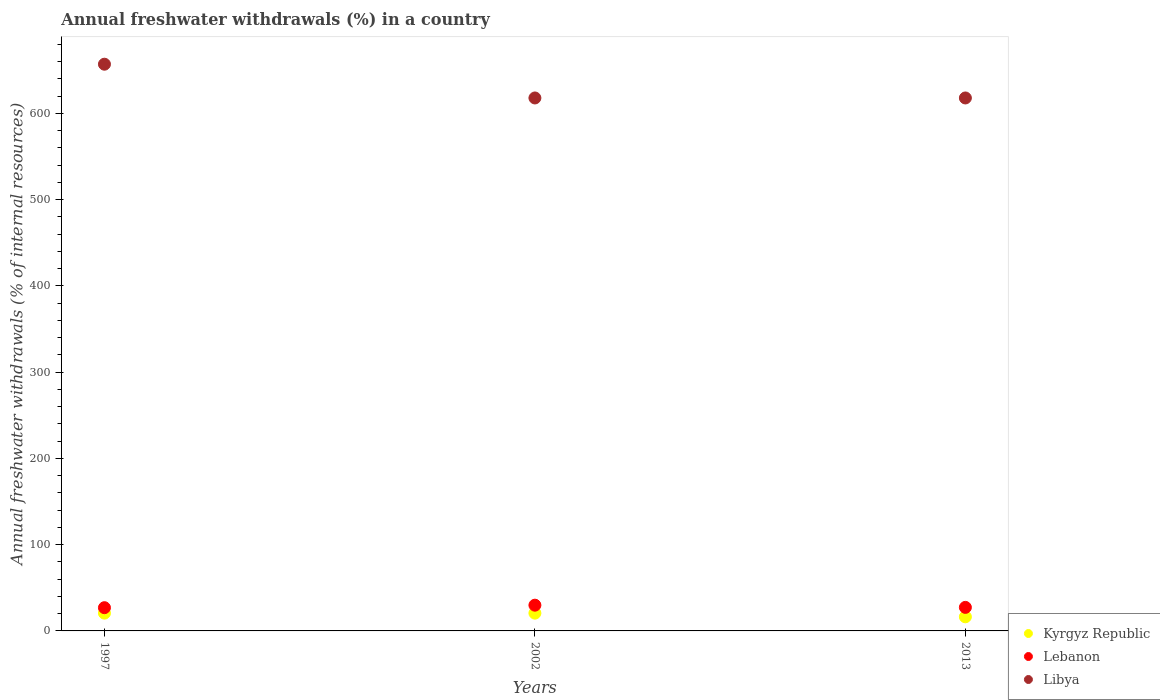How many different coloured dotlines are there?
Ensure brevity in your answer.  3. What is the percentage of annual freshwater withdrawals in Libya in 1997?
Ensure brevity in your answer.  657.14. Across all years, what is the maximum percentage of annual freshwater withdrawals in Kyrgyz Republic?
Provide a succinct answer. 20.62. Across all years, what is the minimum percentage of annual freshwater withdrawals in Lebanon?
Provide a succinct answer. 26.94. In which year was the percentage of annual freshwater withdrawals in Lebanon maximum?
Ensure brevity in your answer.  2002. What is the total percentage of annual freshwater withdrawals in Libya in the graph?
Make the answer very short. 1893.14. What is the difference between the percentage of annual freshwater withdrawals in Kyrgyz Republic in 2002 and that in 2013?
Give a very brief answer. 4.24. What is the difference between the percentage of annual freshwater withdrawals in Libya in 2013 and the percentage of annual freshwater withdrawals in Kyrgyz Republic in 1997?
Provide a succinct answer. 597.38. What is the average percentage of annual freshwater withdrawals in Libya per year?
Your response must be concise. 631.05. In the year 2013, what is the difference between the percentage of annual freshwater withdrawals in Lebanon and percentage of annual freshwater withdrawals in Kyrgyz Republic?
Offer a very short reply. 10.93. What is the ratio of the percentage of annual freshwater withdrawals in Lebanon in 1997 to that in 2002?
Provide a short and direct response. 0.9. Is the percentage of annual freshwater withdrawals in Libya in 2002 less than that in 2013?
Your answer should be very brief. No. Is the difference between the percentage of annual freshwater withdrawals in Lebanon in 1997 and 2002 greater than the difference between the percentage of annual freshwater withdrawals in Kyrgyz Republic in 1997 and 2002?
Provide a succinct answer. No. What is the difference between the highest and the second highest percentage of annual freshwater withdrawals in Kyrgyz Republic?
Make the answer very short. 0.02. What is the difference between the highest and the lowest percentage of annual freshwater withdrawals in Libya?
Provide a succinct answer. 39.14. In how many years, is the percentage of annual freshwater withdrawals in Kyrgyz Republic greater than the average percentage of annual freshwater withdrawals in Kyrgyz Republic taken over all years?
Make the answer very short. 2. Is it the case that in every year, the sum of the percentage of annual freshwater withdrawals in Lebanon and percentage of annual freshwater withdrawals in Kyrgyz Republic  is greater than the percentage of annual freshwater withdrawals in Libya?
Make the answer very short. No. Does the percentage of annual freshwater withdrawals in Lebanon monotonically increase over the years?
Ensure brevity in your answer.  No. Is the percentage of annual freshwater withdrawals in Kyrgyz Republic strictly less than the percentage of annual freshwater withdrawals in Lebanon over the years?
Your answer should be very brief. Yes. How many dotlines are there?
Your response must be concise. 3. What is the difference between two consecutive major ticks on the Y-axis?
Your answer should be compact. 100. Are the values on the major ticks of Y-axis written in scientific E-notation?
Provide a succinct answer. No. Does the graph contain any zero values?
Provide a short and direct response. No. What is the title of the graph?
Offer a very short reply. Annual freshwater withdrawals (%) in a country. Does "Swaziland" appear as one of the legend labels in the graph?
Your answer should be very brief. No. What is the label or title of the Y-axis?
Your response must be concise. Annual freshwater withdrawals (% of internal resources). What is the Annual freshwater withdrawals (% of internal resources) of Kyrgyz Republic in 1997?
Keep it short and to the point. 20.62. What is the Annual freshwater withdrawals (% of internal resources) of Lebanon in 1997?
Provide a short and direct response. 26.94. What is the Annual freshwater withdrawals (% of internal resources) in Libya in 1997?
Your answer should be compact. 657.14. What is the Annual freshwater withdrawals (% of internal resources) in Kyrgyz Republic in 2002?
Your response must be concise. 20.6. What is the Annual freshwater withdrawals (% of internal resources) of Lebanon in 2002?
Your answer should be very brief. 29.85. What is the Annual freshwater withdrawals (% of internal resources) of Libya in 2002?
Your answer should be compact. 618. What is the Annual freshwater withdrawals (% of internal resources) in Kyrgyz Republic in 2013?
Your answer should be compact. 16.36. What is the Annual freshwater withdrawals (% of internal resources) in Lebanon in 2013?
Make the answer very short. 27.29. What is the Annual freshwater withdrawals (% of internal resources) of Libya in 2013?
Provide a short and direct response. 618. Across all years, what is the maximum Annual freshwater withdrawals (% of internal resources) of Kyrgyz Republic?
Offer a very short reply. 20.62. Across all years, what is the maximum Annual freshwater withdrawals (% of internal resources) of Lebanon?
Offer a terse response. 29.85. Across all years, what is the maximum Annual freshwater withdrawals (% of internal resources) in Libya?
Offer a very short reply. 657.14. Across all years, what is the minimum Annual freshwater withdrawals (% of internal resources) in Kyrgyz Republic?
Give a very brief answer. 16.36. Across all years, what is the minimum Annual freshwater withdrawals (% of internal resources) in Lebanon?
Offer a very short reply. 26.94. Across all years, what is the minimum Annual freshwater withdrawals (% of internal resources) in Libya?
Keep it short and to the point. 618. What is the total Annual freshwater withdrawals (% of internal resources) in Kyrgyz Republic in the graph?
Give a very brief answer. 57.59. What is the total Annual freshwater withdrawals (% of internal resources) of Lebanon in the graph?
Give a very brief answer. 84.08. What is the total Annual freshwater withdrawals (% of internal resources) of Libya in the graph?
Ensure brevity in your answer.  1893.14. What is the difference between the Annual freshwater withdrawals (% of internal resources) of Kyrgyz Republic in 1997 and that in 2002?
Give a very brief answer. 0.02. What is the difference between the Annual freshwater withdrawals (% of internal resources) in Lebanon in 1997 and that in 2002?
Offer a very short reply. -2.92. What is the difference between the Annual freshwater withdrawals (% of internal resources) of Libya in 1997 and that in 2002?
Keep it short and to the point. 39.14. What is the difference between the Annual freshwater withdrawals (% of internal resources) in Kyrgyz Republic in 1997 and that in 2013?
Provide a short and direct response. 4.26. What is the difference between the Annual freshwater withdrawals (% of internal resources) in Lebanon in 1997 and that in 2013?
Provide a succinct answer. -0.35. What is the difference between the Annual freshwater withdrawals (% of internal resources) of Libya in 1997 and that in 2013?
Your answer should be compact. 39.14. What is the difference between the Annual freshwater withdrawals (% of internal resources) in Kyrgyz Republic in 2002 and that in 2013?
Provide a short and direct response. 4.24. What is the difference between the Annual freshwater withdrawals (% of internal resources) in Lebanon in 2002 and that in 2013?
Provide a succinct answer. 2.56. What is the difference between the Annual freshwater withdrawals (% of internal resources) of Kyrgyz Republic in 1997 and the Annual freshwater withdrawals (% of internal resources) of Lebanon in 2002?
Provide a short and direct response. -9.23. What is the difference between the Annual freshwater withdrawals (% of internal resources) of Kyrgyz Republic in 1997 and the Annual freshwater withdrawals (% of internal resources) of Libya in 2002?
Give a very brief answer. -597.38. What is the difference between the Annual freshwater withdrawals (% of internal resources) in Lebanon in 1997 and the Annual freshwater withdrawals (% of internal resources) in Libya in 2002?
Your answer should be very brief. -591.06. What is the difference between the Annual freshwater withdrawals (% of internal resources) in Kyrgyz Republic in 1997 and the Annual freshwater withdrawals (% of internal resources) in Lebanon in 2013?
Your answer should be very brief. -6.67. What is the difference between the Annual freshwater withdrawals (% of internal resources) of Kyrgyz Republic in 1997 and the Annual freshwater withdrawals (% of internal resources) of Libya in 2013?
Offer a very short reply. -597.38. What is the difference between the Annual freshwater withdrawals (% of internal resources) of Lebanon in 1997 and the Annual freshwater withdrawals (% of internal resources) of Libya in 2013?
Offer a terse response. -591.06. What is the difference between the Annual freshwater withdrawals (% of internal resources) in Kyrgyz Republic in 2002 and the Annual freshwater withdrawals (% of internal resources) in Lebanon in 2013?
Ensure brevity in your answer.  -6.69. What is the difference between the Annual freshwater withdrawals (% of internal resources) in Kyrgyz Republic in 2002 and the Annual freshwater withdrawals (% of internal resources) in Libya in 2013?
Offer a very short reply. -597.4. What is the difference between the Annual freshwater withdrawals (% of internal resources) in Lebanon in 2002 and the Annual freshwater withdrawals (% of internal resources) in Libya in 2013?
Offer a terse response. -588.15. What is the average Annual freshwater withdrawals (% of internal resources) in Kyrgyz Republic per year?
Offer a very short reply. 19.2. What is the average Annual freshwater withdrawals (% of internal resources) of Lebanon per year?
Make the answer very short. 28.03. What is the average Annual freshwater withdrawals (% of internal resources) in Libya per year?
Your answer should be compact. 631.05. In the year 1997, what is the difference between the Annual freshwater withdrawals (% of internal resources) of Kyrgyz Republic and Annual freshwater withdrawals (% of internal resources) of Lebanon?
Offer a very short reply. -6.32. In the year 1997, what is the difference between the Annual freshwater withdrawals (% of internal resources) of Kyrgyz Republic and Annual freshwater withdrawals (% of internal resources) of Libya?
Your answer should be very brief. -636.52. In the year 1997, what is the difference between the Annual freshwater withdrawals (% of internal resources) of Lebanon and Annual freshwater withdrawals (% of internal resources) of Libya?
Your response must be concise. -630.21. In the year 2002, what is the difference between the Annual freshwater withdrawals (% of internal resources) in Kyrgyz Republic and Annual freshwater withdrawals (% of internal resources) in Lebanon?
Make the answer very short. -9.25. In the year 2002, what is the difference between the Annual freshwater withdrawals (% of internal resources) of Kyrgyz Republic and Annual freshwater withdrawals (% of internal resources) of Libya?
Ensure brevity in your answer.  -597.4. In the year 2002, what is the difference between the Annual freshwater withdrawals (% of internal resources) of Lebanon and Annual freshwater withdrawals (% of internal resources) of Libya?
Make the answer very short. -588.15. In the year 2013, what is the difference between the Annual freshwater withdrawals (% of internal resources) in Kyrgyz Republic and Annual freshwater withdrawals (% of internal resources) in Lebanon?
Make the answer very short. -10.93. In the year 2013, what is the difference between the Annual freshwater withdrawals (% of internal resources) of Kyrgyz Republic and Annual freshwater withdrawals (% of internal resources) of Libya?
Offer a terse response. -601.64. In the year 2013, what is the difference between the Annual freshwater withdrawals (% of internal resources) in Lebanon and Annual freshwater withdrawals (% of internal resources) in Libya?
Your answer should be very brief. -590.71. What is the ratio of the Annual freshwater withdrawals (% of internal resources) in Lebanon in 1997 to that in 2002?
Keep it short and to the point. 0.9. What is the ratio of the Annual freshwater withdrawals (% of internal resources) in Libya in 1997 to that in 2002?
Provide a succinct answer. 1.06. What is the ratio of the Annual freshwater withdrawals (% of internal resources) of Kyrgyz Republic in 1997 to that in 2013?
Provide a short and direct response. 1.26. What is the ratio of the Annual freshwater withdrawals (% of internal resources) in Lebanon in 1997 to that in 2013?
Your answer should be compact. 0.99. What is the ratio of the Annual freshwater withdrawals (% of internal resources) in Libya in 1997 to that in 2013?
Ensure brevity in your answer.  1.06. What is the ratio of the Annual freshwater withdrawals (% of internal resources) of Kyrgyz Republic in 2002 to that in 2013?
Your answer should be very brief. 1.26. What is the ratio of the Annual freshwater withdrawals (% of internal resources) of Lebanon in 2002 to that in 2013?
Give a very brief answer. 1.09. What is the ratio of the Annual freshwater withdrawals (% of internal resources) in Libya in 2002 to that in 2013?
Provide a succinct answer. 1. What is the difference between the highest and the second highest Annual freshwater withdrawals (% of internal resources) in Kyrgyz Republic?
Give a very brief answer. 0.02. What is the difference between the highest and the second highest Annual freshwater withdrawals (% of internal resources) in Lebanon?
Your answer should be very brief. 2.56. What is the difference between the highest and the second highest Annual freshwater withdrawals (% of internal resources) of Libya?
Your answer should be compact. 39.14. What is the difference between the highest and the lowest Annual freshwater withdrawals (% of internal resources) in Kyrgyz Republic?
Your answer should be compact. 4.26. What is the difference between the highest and the lowest Annual freshwater withdrawals (% of internal resources) in Lebanon?
Your response must be concise. 2.92. What is the difference between the highest and the lowest Annual freshwater withdrawals (% of internal resources) of Libya?
Provide a short and direct response. 39.14. 